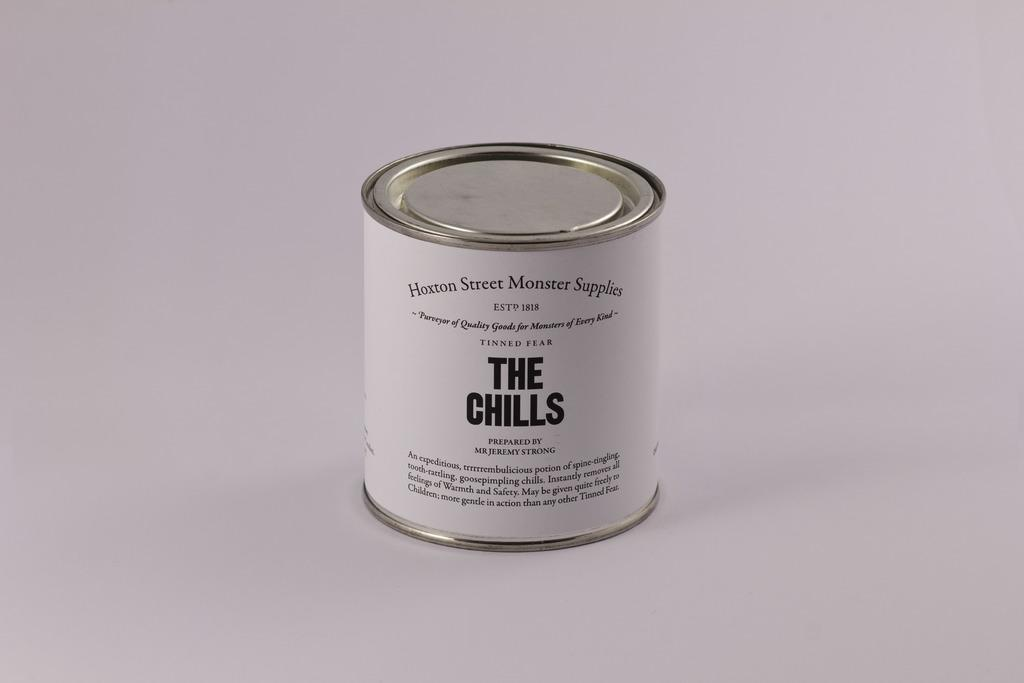<image>
Describe the image concisely. small white can has a label that says The Chills. 